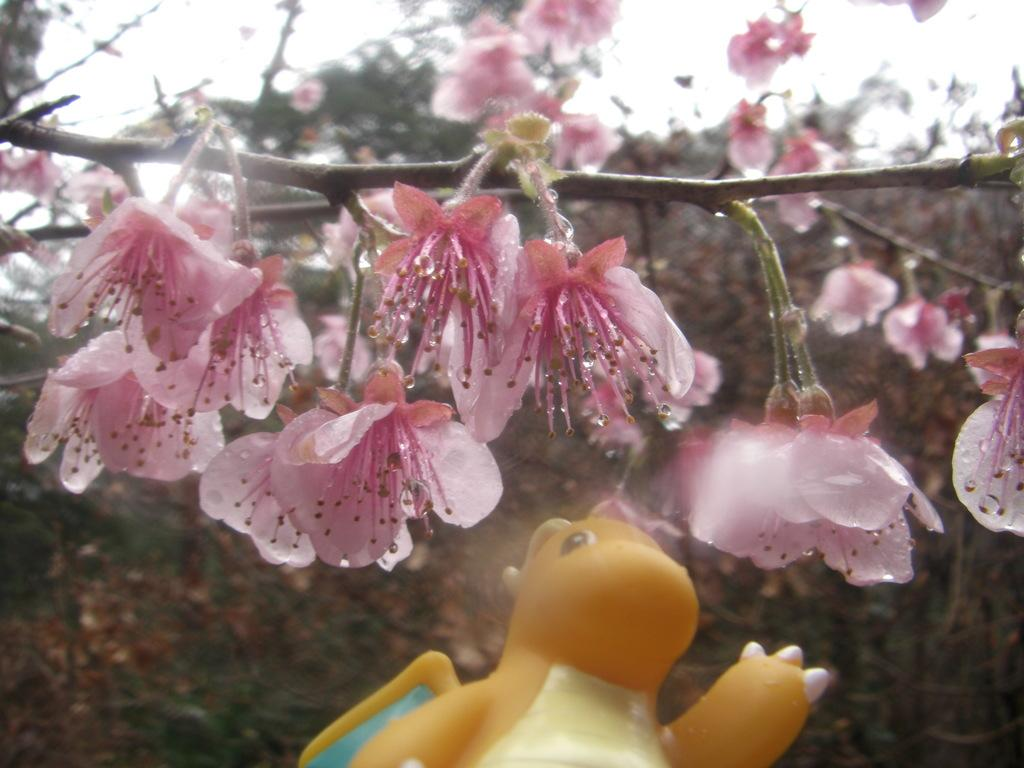What type of flowers can be seen in the image? There are pink color flowers in the image. What other object is present at the bottom of the image? There is a toy at the bottom of the image. What can be seen in the background of the image? There are trees in the background of the image. What is visible at the top of the image? The sky is visible at the top of the image. What type of paint is being used by the dogs in the image? There are no dogs present in the image, so there is no paint being used. What learning materials can be seen in the image? There are no learning materials visible in the image. 